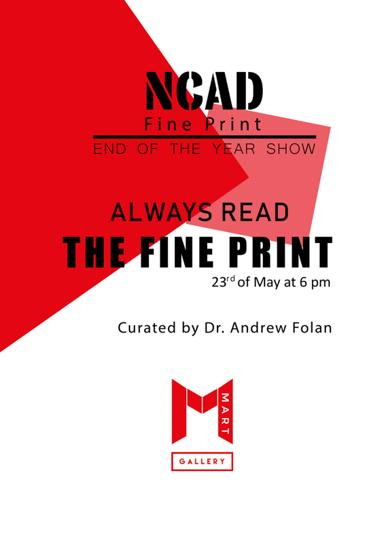How does the color scheme of the poster affect its appeal? The vibrant red against the stark white background creates a commanding visual contrast that not only grabs attention but also invokes a sense of excitement and urgency, fitting for the final showcase of the year. 